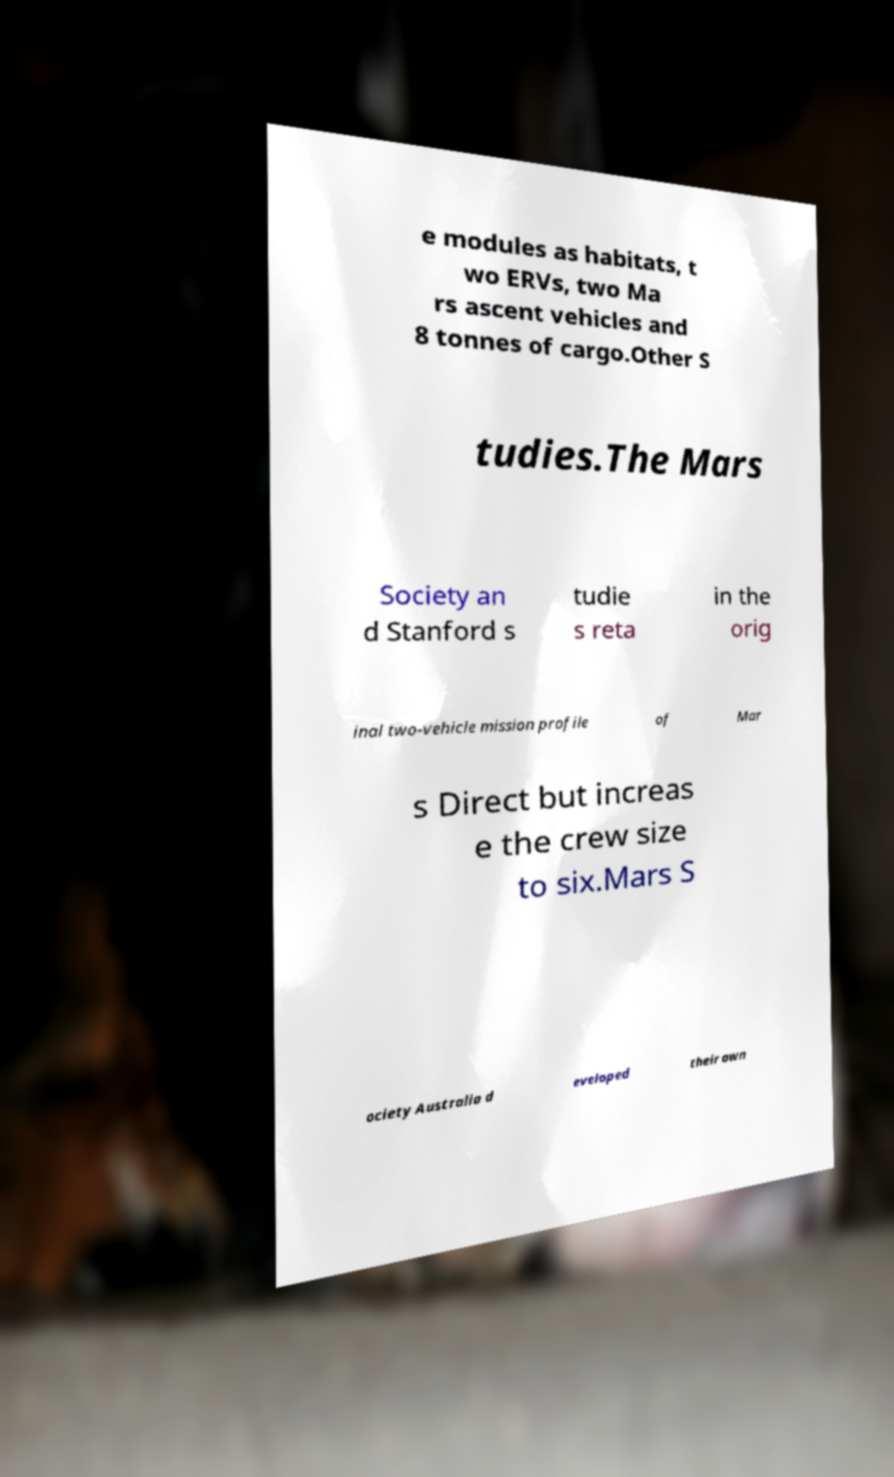Please identify and transcribe the text found in this image. e modules as habitats, t wo ERVs, two Ma rs ascent vehicles and 8 tonnes of cargo.Other S tudies.The Mars Society an d Stanford s tudie s reta in the orig inal two-vehicle mission profile of Mar s Direct but increas e the crew size to six.Mars S ociety Australia d eveloped their own 